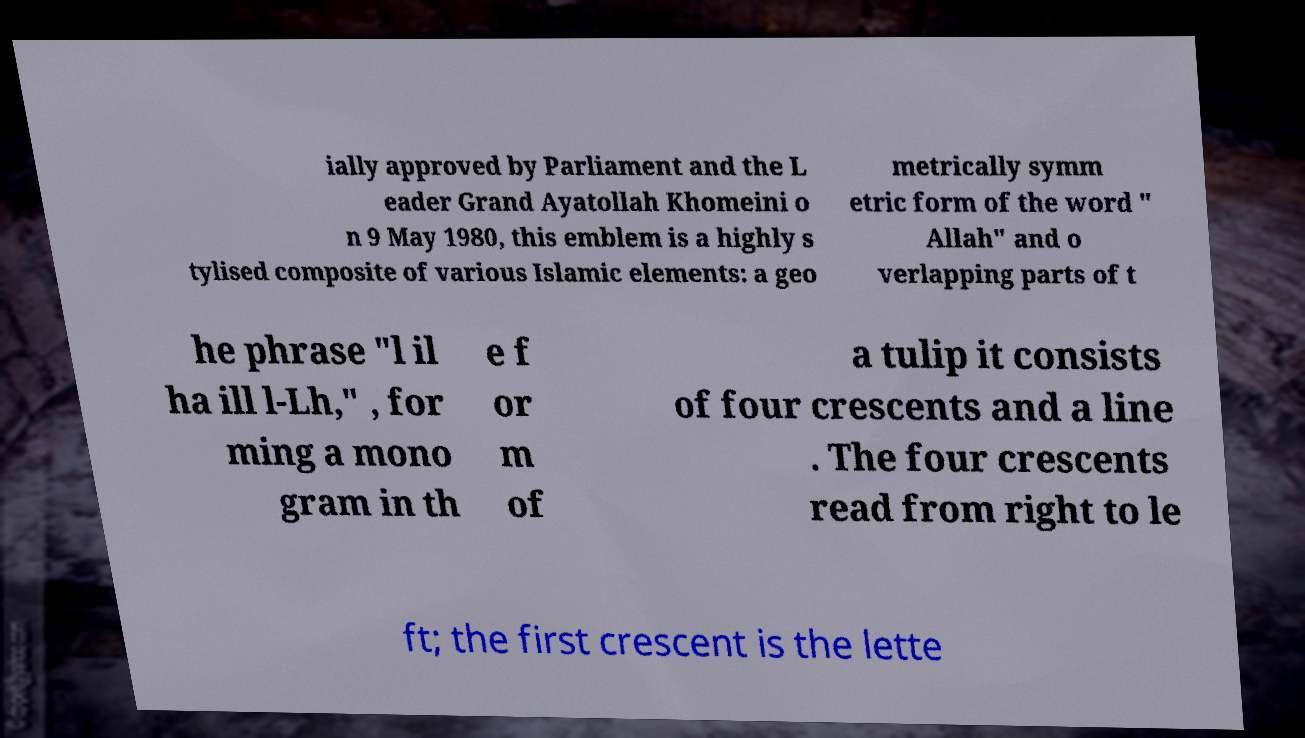Please read and relay the text visible in this image. What does it say? ially approved by Parliament and the L eader Grand Ayatollah Khomeini o n 9 May 1980, this emblem is a highly s tylised composite of various Islamic elements: a geo metrically symm etric form of the word " Allah" and o verlapping parts of t he phrase "l il ha ill l-Lh," , for ming a mono gram in th e f or m of a tulip it consists of four crescents and a line . The four crescents read from right to le ft; the first crescent is the lette 